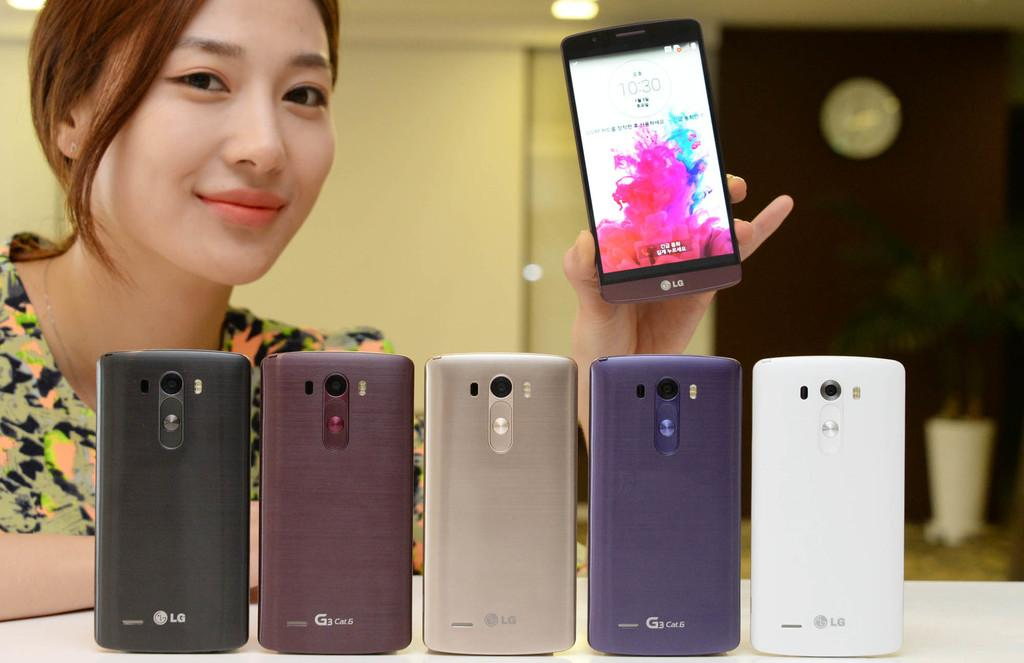<image>
Describe the image concisely. A row of LG brand smartphones standing in a row as a woman is holding a phone 